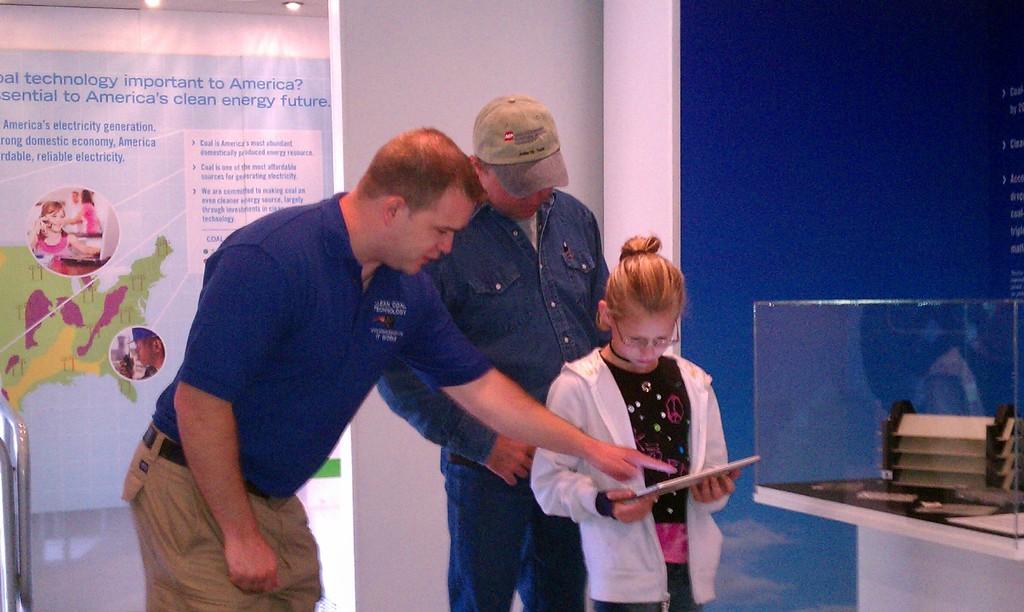Is the sign in the back about clean energy?
Your response must be concise. Yes. What is the last word in the headline of the poster in the back?
Make the answer very short. Future. 